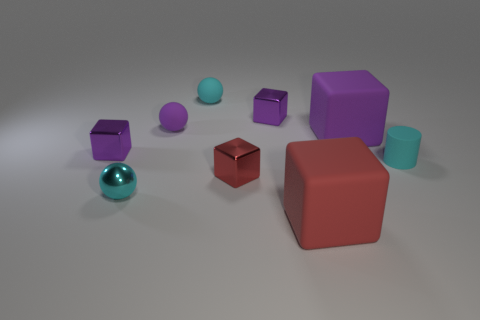Can you describe the arrangement of objects and what it might suggest about spatial balance? The objects are arranged with a sense of deliberate asymmetry. The various shapes and sizes, along with their placement, create a dynamic scene that suggests a playful exploration of balance and composition. 